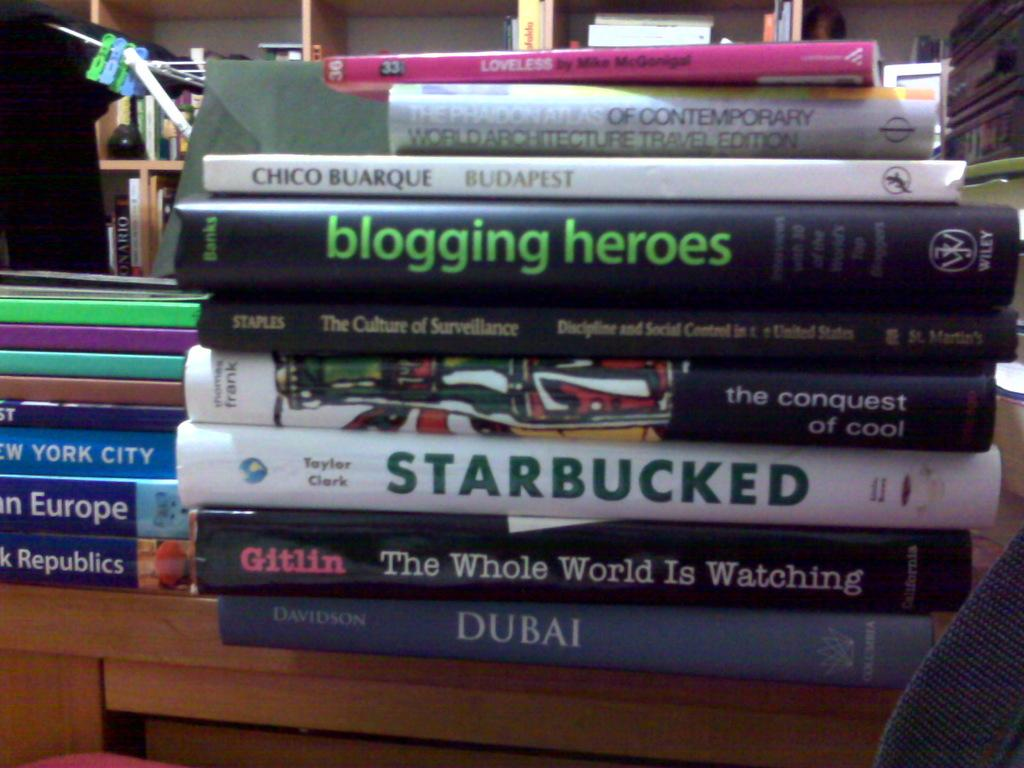<image>
Give a short and clear explanation of the subsequent image. White Starbucked book by Taylor Clark in the middle of other books. 